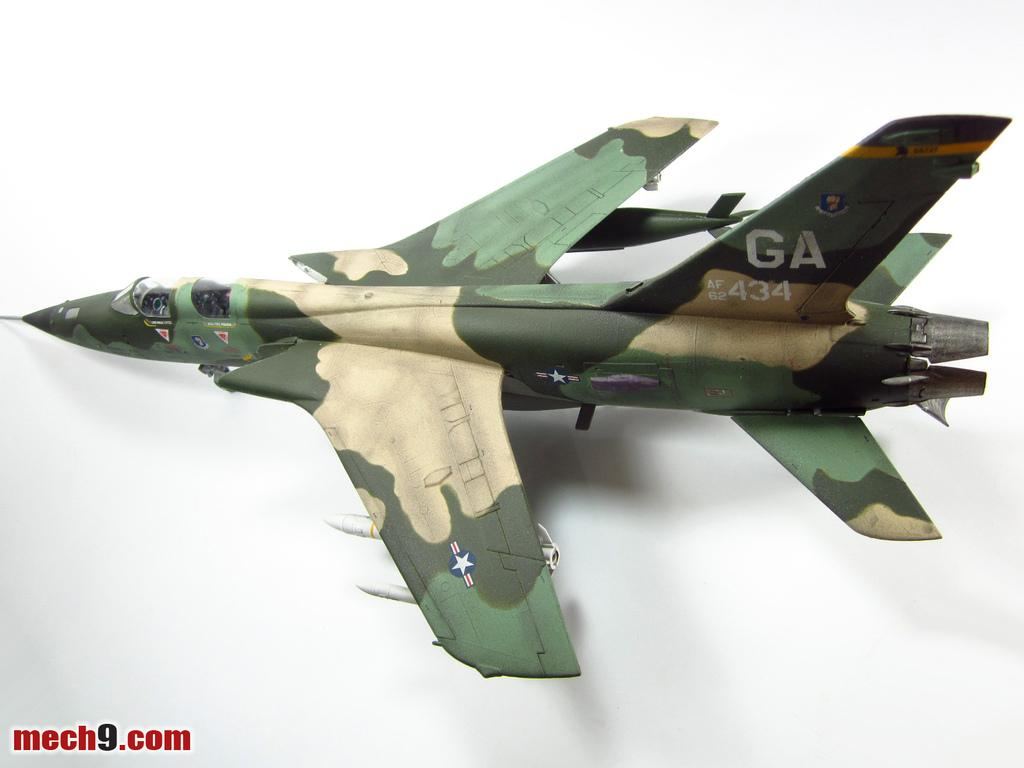<image>
Write a terse but informative summary of the picture. the green camo plane with a GA on the tail is a midel 